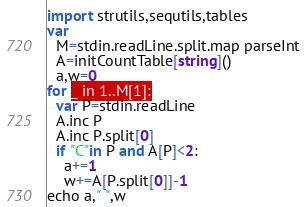<code> <loc_0><loc_0><loc_500><loc_500><_Nim_>import strutils,sequtils,tables
var
  M=stdin.readLine.split.map parseInt
  A=initCountTable[string]()
  a,w=0
for _ in 1..M[1]:
  var P=stdin.readLine
  A.inc P
  A.inc P.split[0]
  if "C"in P and A[P]<2:
    a+=1
    w+=A[P.split[0]]-1
echo a," ",w</code> 